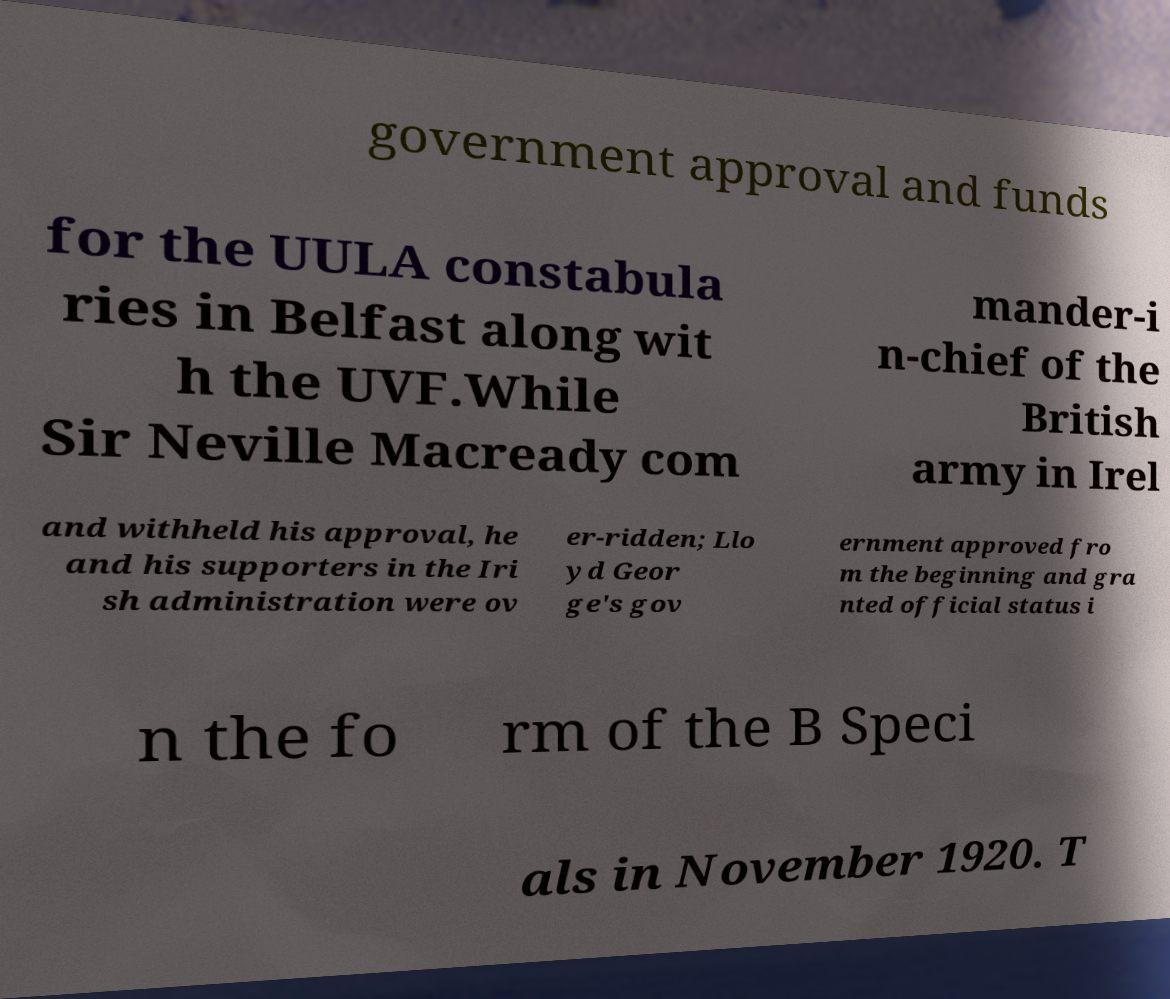There's text embedded in this image that I need extracted. Can you transcribe it verbatim? government approval and funds for the UULA constabula ries in Belfast along wit h the UVF.While Sir Neville Macready com mander-i n-chief of the British army in Irel and withheld his approval, he and his supporters in the Iri sh administration were ov er-ridden; Llo yd Geor ge's gov ernment approved fro m the beginning and gra nted official status i n the fo rm of the B Speci als in November 1920. T 